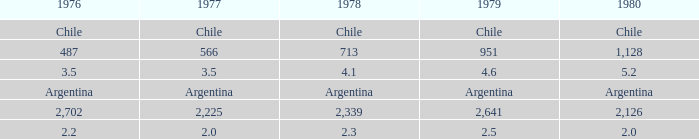What is 1977 when 1978 is 4.1? 3.5. 